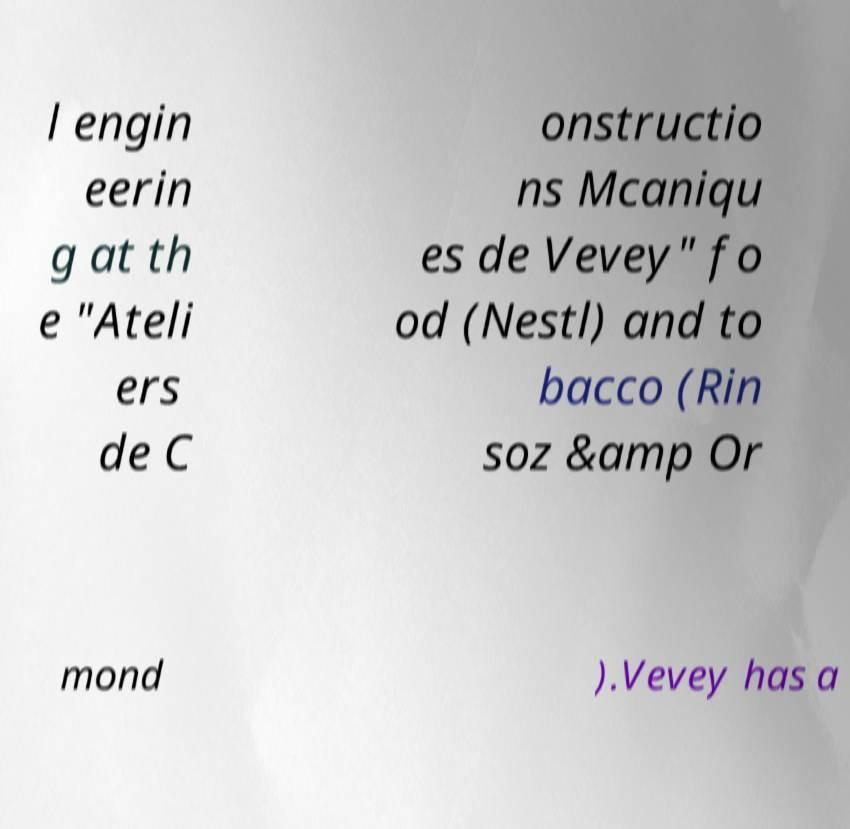What messages or text are displayed in this image? I need them in a readable, typed format. l engin eerin g at th e "Ateli ers de C onstructio ns Mcaniqu es de Vevey" fo od (Nestl) and to bacco (Rin soz &amp Or mond ).Vevey has a 